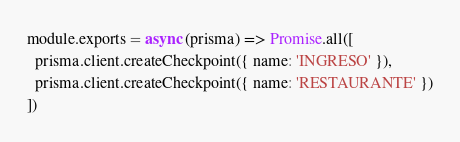Convert code to text. <code><loc_0><loc_0><loc_500><loc_500><_JavaScript_>module.exports = async (prisma) => Promise.all([
  prisma.client.createCheckpoint({ name: 'INGRESO' }),
  prisma.client.createCheckpoint({ name: 'RESTAURANTE' })
])</code> 